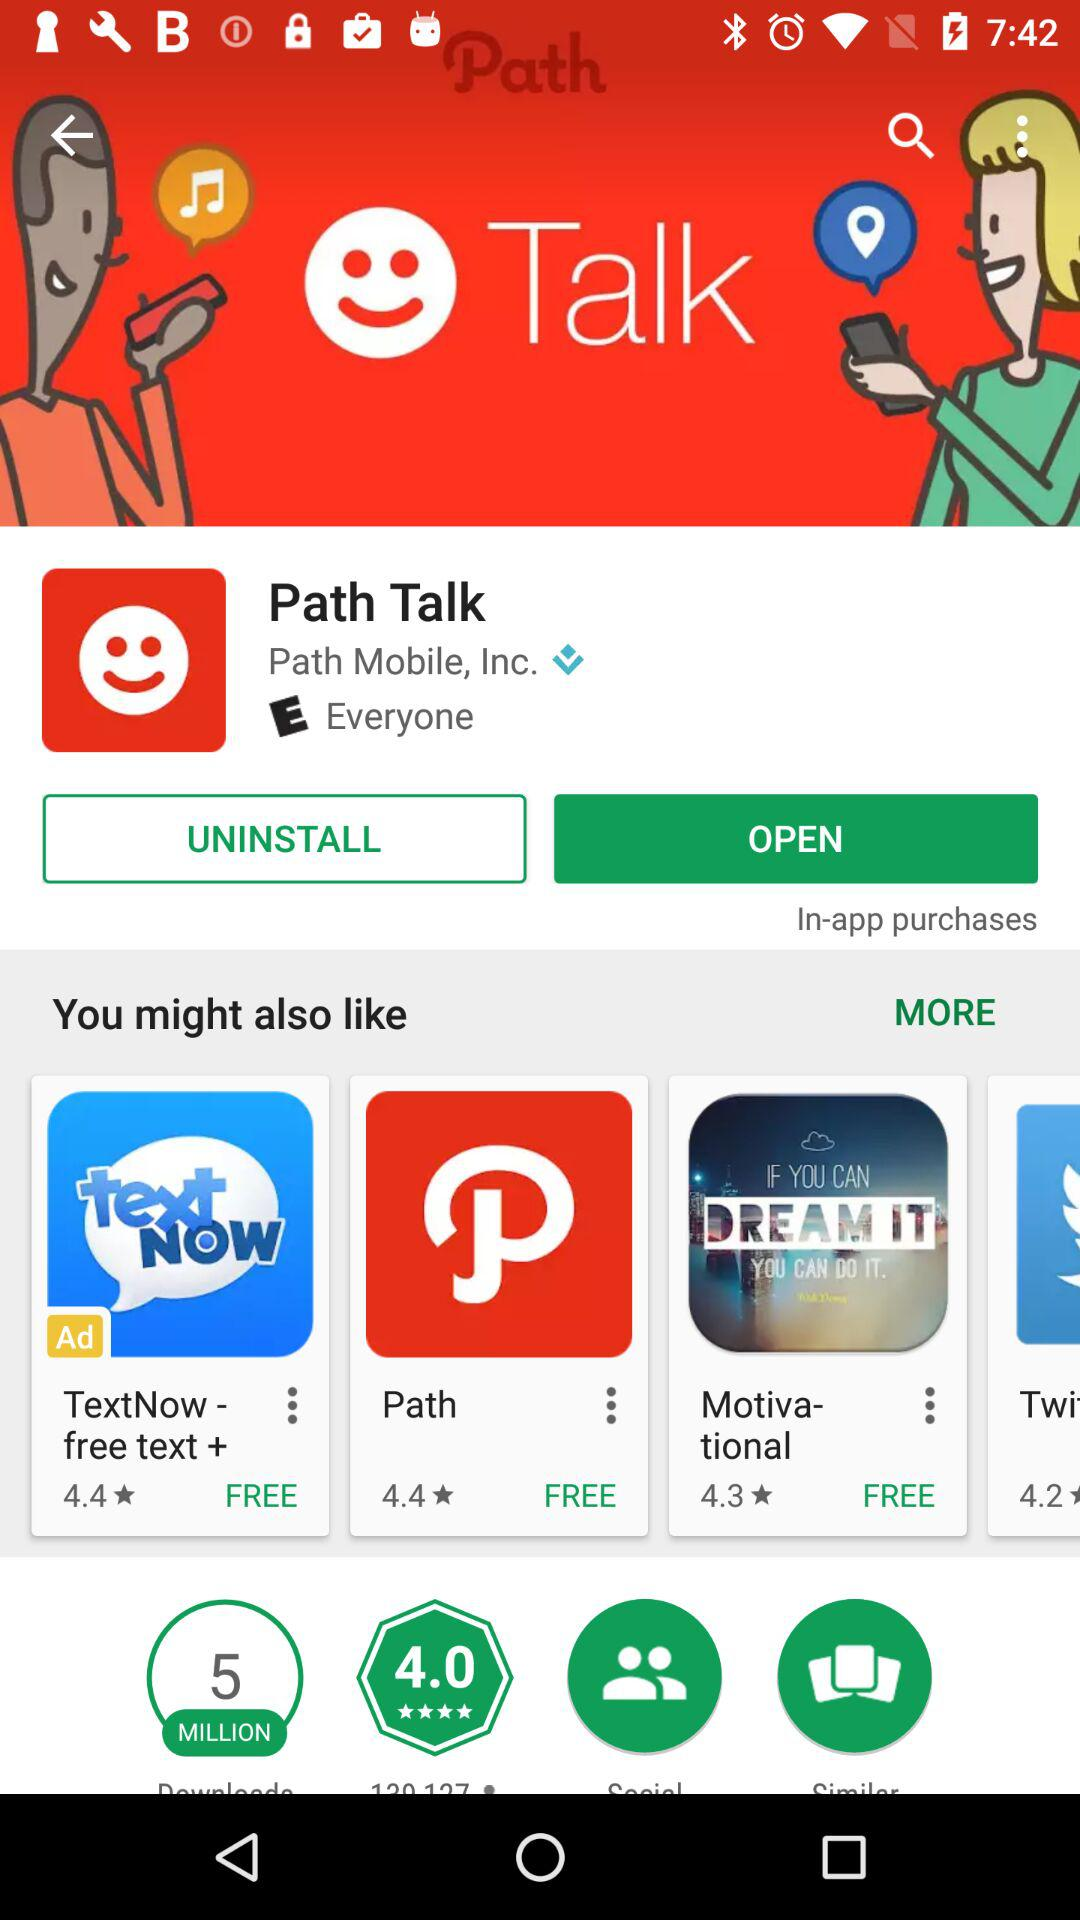Which tab is selected currently among open or uninstalled?
When the provided information is insufficient, respond with <no answer>. <no answer> 